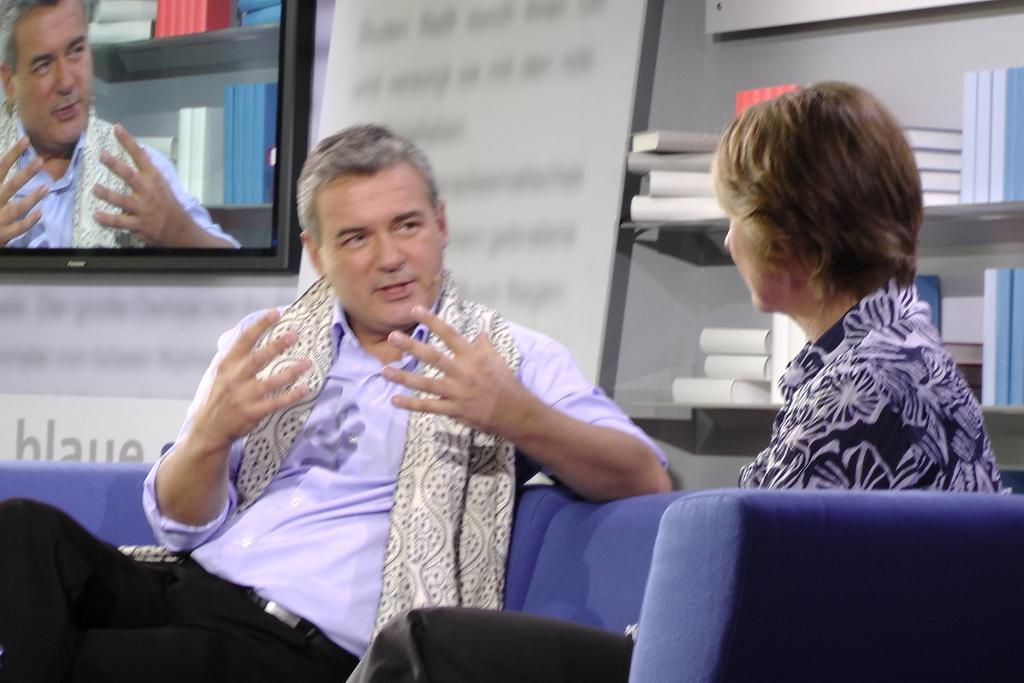Who are the people in the image? There is a man and a woman in the image. What are they doing in the image? They are sitting on a sofa. What can be seen in the background of the image? There are many books in a shelf. What electronic device is present in the image? There is a television in the image. What type of brush is being used to exercise the man's muscles in the image? There is no brush or exercise of muscles depicted in the image; it features a man and a woman sitting on a sofa with books in the background and a television present. 